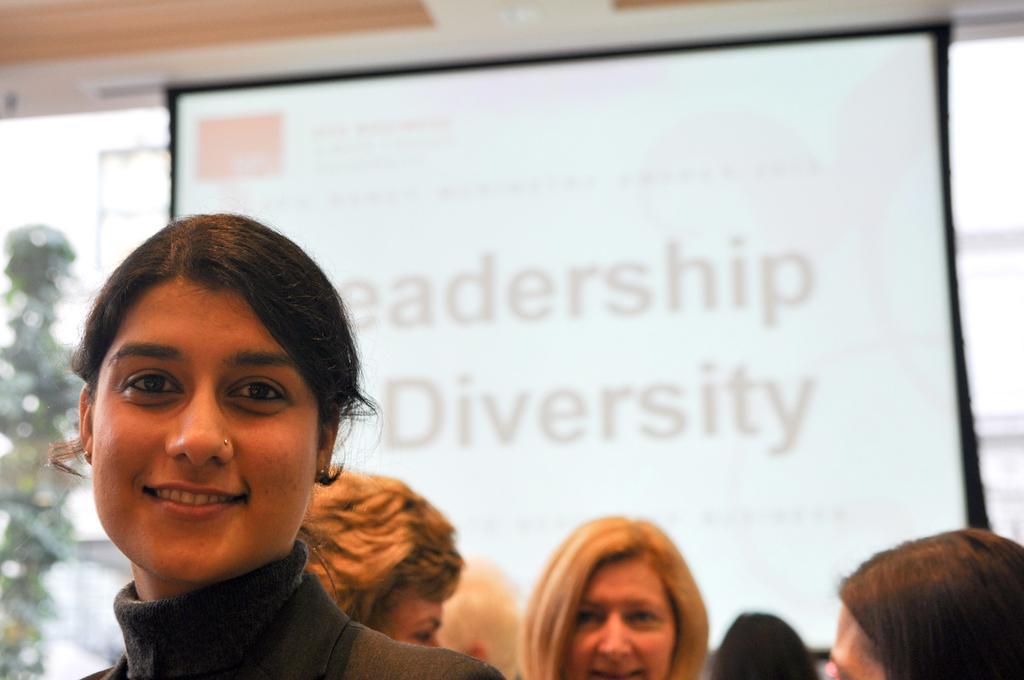Could you give a brief overview of what you see in this image? In the picture we can see a woman standing and smiling behind her we can see three more woman are standing and talking to each other and behind them we can see a screen on it we can see a topic about leadership diversity and beside the screen we can see some plant near the wall. 